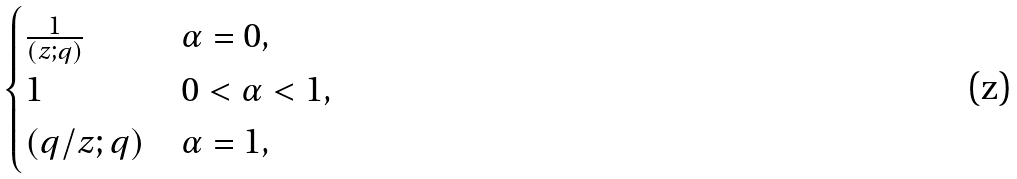<formula> <loc_0><loc_0><loc_500><loc_500>\begin{cases} \frac { 1 } { ( z ; q ) } & \alpha = 0 , \\ 1 & 0 < \alpha < 1 , \\ ( q / z ; q ) & \alpha = 1 , \end{cases}</formula> 